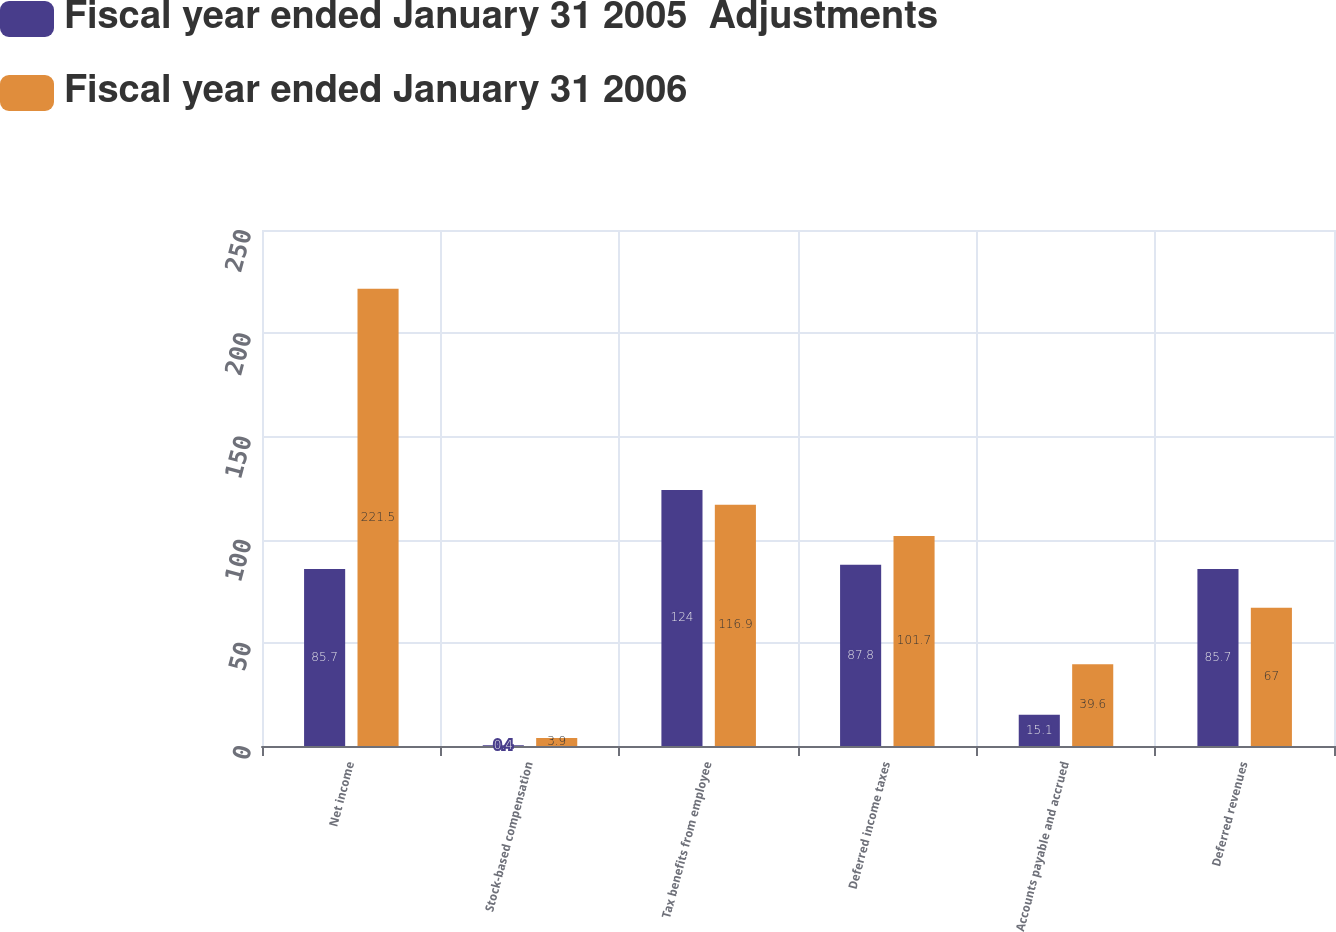Convert chart. <chart><loc_0><loc_0><loc_500><loc_500><stacked_bar_chart><ecel><fcel>Net income<fcel>Stock-based compensation<fcel>Tax benefits from employee<fcel>Deferred income taxes<fcel>Accounts payable and accrued<fcel>Deferred revenues<nl><fcel>Fiscal year ended January 31 2005  Adjustments<fcel>85.7<fcel>0.4<fcel>124<fcel>87.8<fcel>15.1<fcel>85.7<nl><fcel>Fiscal year ended January 31 2006<fcel>221.5<fcel>3.9<fcel>116.9<fcel>101.7<fcel>39.6<fcel>67<nl></chart> 